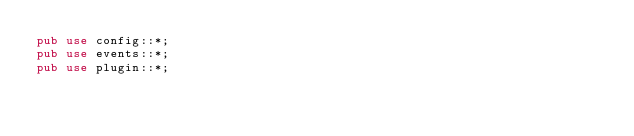<code> <loc_0><loc_0><loc_500><loc_500><_Rust_>pub use config::*;
pub use events::*;
pub use plugin::*;
</code> 